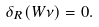Convert formula to latex. <formula><loc_0><loc_0><loc_500><loc_500>\delta _ { R } ( W \nu ) = 0 .</formula> 